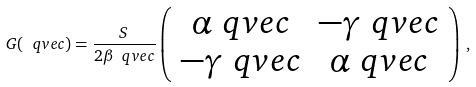Convert formula to latex. <formula><loc_0><loc_0><loc_500><loc_500>G ( \ q v e c ) = \frac { S } { 2 \beta _ { \ } q v e c } \left ( \begin{array} { c c } \alpha _ { \ } q v e c & - \gamma _ { \ } q v e c \\ - \gamma _ { \ } q v e c & \alpha _ { \ } q v e c \end{array} \right ) \, ,</formula> 